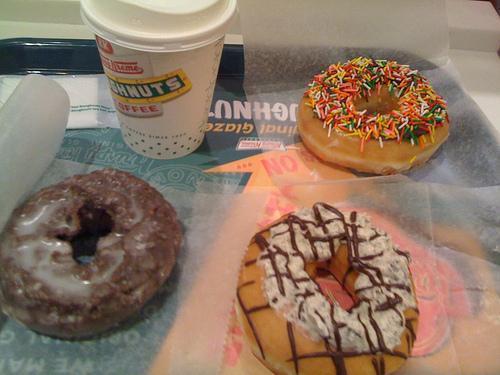How many consumable items are pictured?
Give a very brief answer. 4. How many donuts are visible?
Give a very brief answer. 3. How many people in the photo?
Give a very brief answer. 0. 